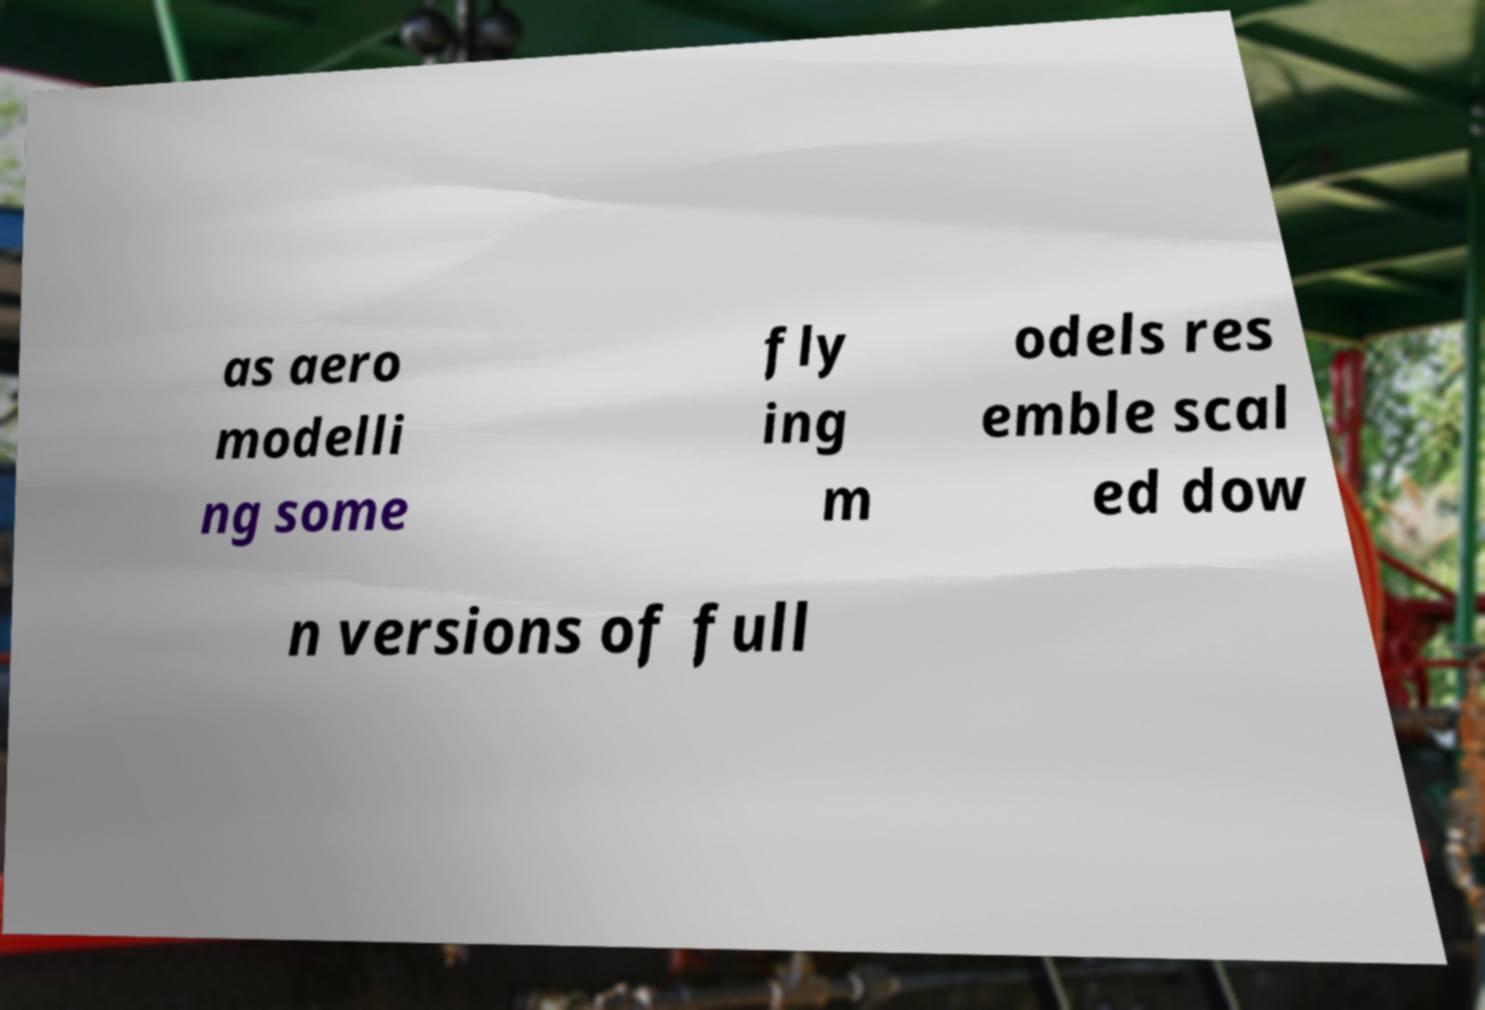Please identify and transcribe the text found in this image. as aero modelli ng some fly ing m odels res emble scal ed dow n versions of full 